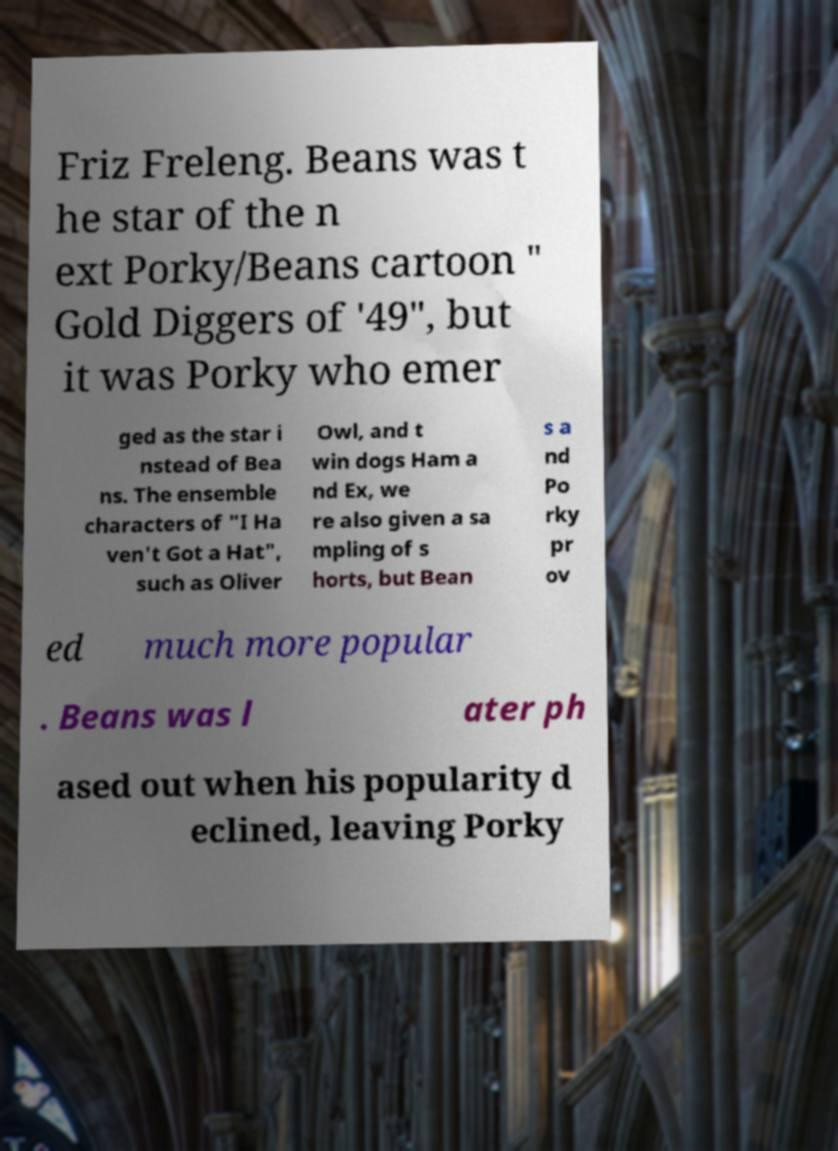Please read and relay the text visible in this image. What does it say? Friz Freleng. Beans was t he star of the n ext Porky/Beans cartoon " Gold Diggers of '49", but it was Porky who emer ged as the star i nstead of Bea ns. The ensemble characters of "I Ha ven't Got a Hat", such as Oliver Owl, and t win dogs Ham a nd Ex, we re also given a sa mpling of s horts, but Bean s a nd Po rky pr ov ed much more popular . Beans was l ater ph ased out when his popularity d eclined, leaving Porky 